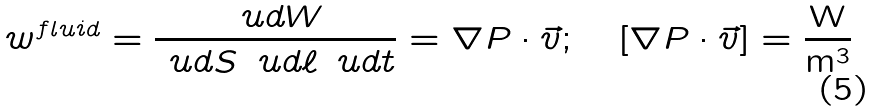Convert formula to latex. <formula><loc_0><loc_0><loc_500><loc_500>w ^ { f l u i d } = \frac { \ u d W } { \ u d S \, \ u d \ell \, \ u d t } = \nabla P \cdot \vec { v } ; \quad [ \nabla P \cdot \vec { v } ] = \frac { \text {W} } { \text {m} ^ { 3 } }</formula> 